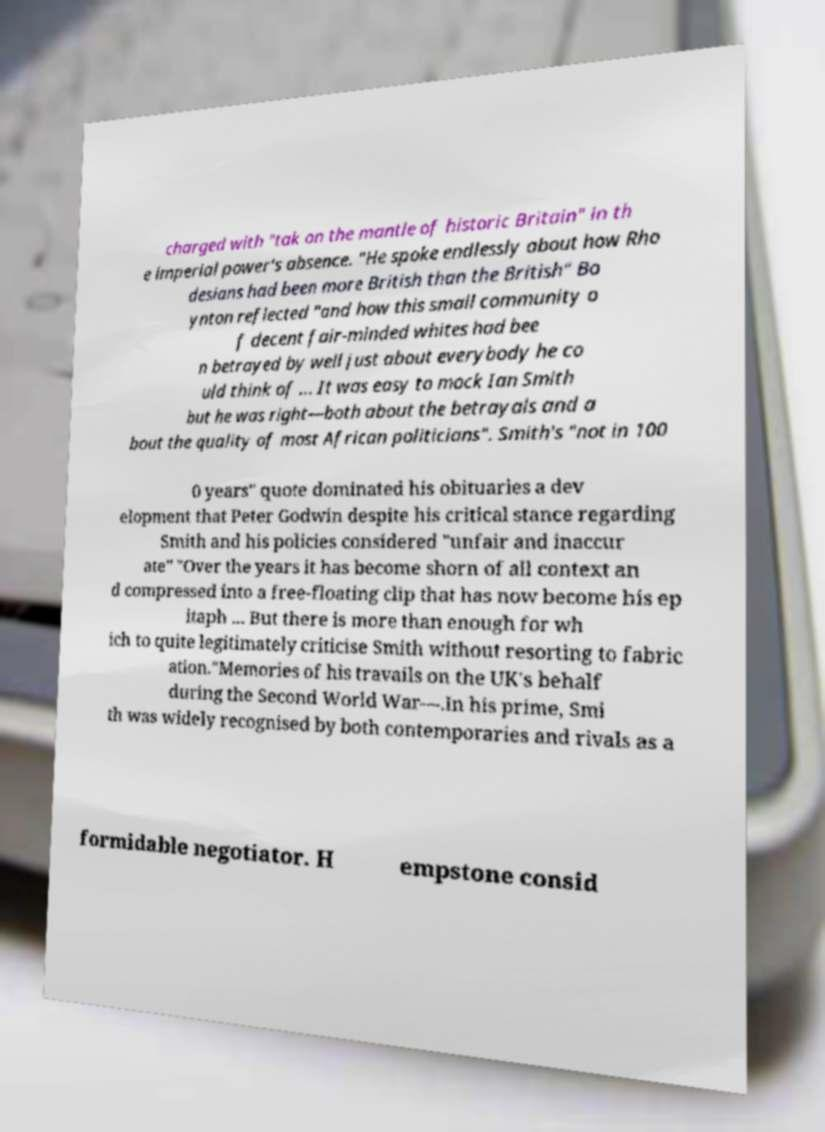Could you assist in decoding the text presented in this image and type it out clearly? charged with "tak on the mantle of historic Britain" in th e imperial power's absence. "He spoke endlessly about how Rho desians had been more British than the British" Bo ynton reflected "and how this small community o f decent fair-minded whites had bee n betrayed by well just about everybody he co uld think of ... It was easy to mock Ian Smith but he was right—both about the betrayals and a bout the quality of most African politicians". Smith's "not in 100 0 years" quote dominated his obituaries a dev elopment that Peter Godwin despite his critical stance regarding Smith and his policies considered "unfair and inaccur ate" "Over the years it has become shorn of all context an d compressed into a free-floating clip that has now become his ep itaph ... But there is more than enough for wh ich to quite legitimately criticise Smith without resorting to fabric ation."Memories of his travails on the UK's behalf during the Second World War—.In his prime, Smi th was widely recognised by both contemporaries and rivals as a formidable negotiator. H empstone consid 